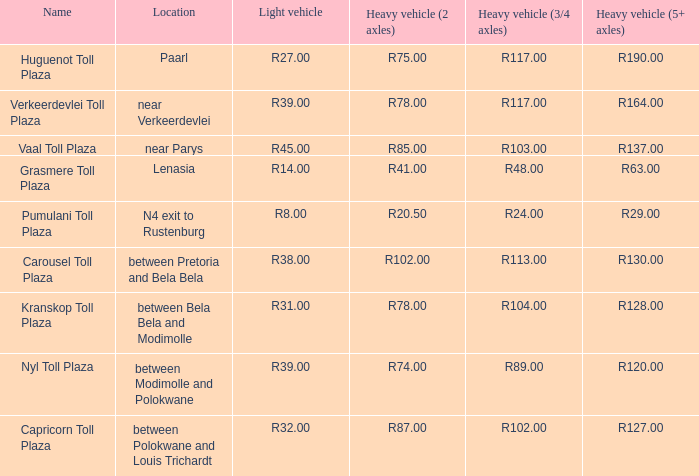What is the title of the public space where the fee for massive vehicles having 2 axles equals r8 Capricorn Toll Plaza. 